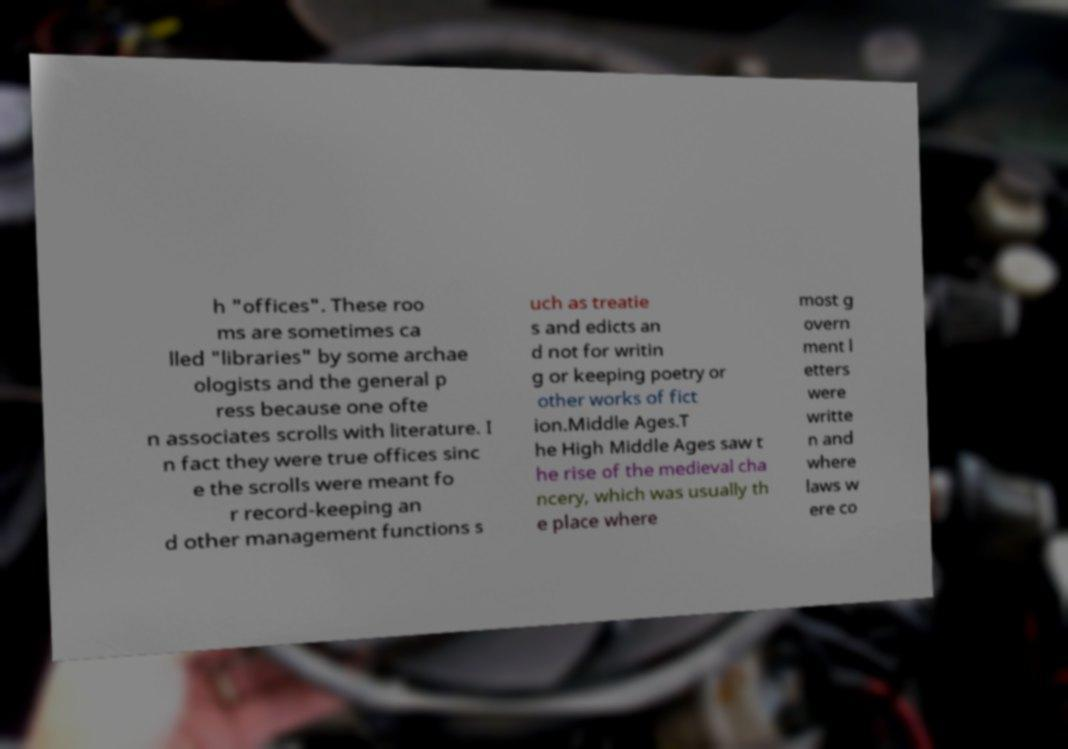I need the written content from this picture converted into text. Can you do that? h "offices". These roo ms are sometimes ca lled "libraries" by some archae ologists and the general p ress because one ofte n associates scrolls with literature. I n fact they were true offices sinc e the scrolls were meant fo r record-keeping an d other management functions s uch as treatie s and edicts an d not for writin g or keeping poetry or other works of fict ion.Middle Ages.T he High Middle Ages saw t he rise of the medieval cha ncery, which was usually th e place where most g overn ment l etters were writte n and where laws w ere co 